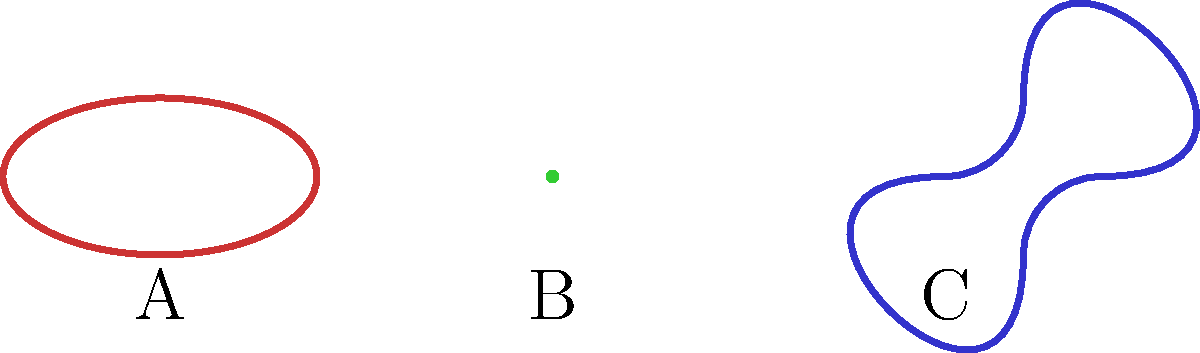As a university dean seeking to enhance student learning in astronomy, you come across this diagram illustrating three simplified shapes of galaxies. Which shape, labeled A, B, or C, most likely represents a spiral galaxy, and why would this be important for students to understand in the context of galactic evolution? To answer this question, let's analyze each shape and relate it to known galaxy types:

1. Shape A: This is an elliptical shape, characteristic of elliptical galaxies. These are typically older galaxies with little gas and dust, and minimal star formation.

2. Shape B: This is a circular shape with a slight spiral hint, most closely resembling a spiral galaxy. Spiral galaxies have a central bulge and spiral arms, often containing regions of active star formation.

3. Shape C: This irregular shape doesn't conform to a specific pattern, representative of irregular galaxies. These are often the result of galactic collisions or interactions.

The correct answer is B, as it most closely resembles a spiral galaxy. 

Understanding galaxy shapes is crucial for students in the context of galactic evolution because:

1. It helps students visualize the different stages of galactic life cycles.
2. Shape relates to the galaxy's composition, age, and star formation rate.
3. It aids in understanding galactic interactions and mergers.
4. It provides insight into the distribution of matter in the universe.
5. It helps in classifying and studying distant galaxies observed through telescopes.

By recognizing these shapes, students can better grasp the complex processes involved in galactic formation and evolution, enhancing their overall understanding of the universe's structure and history.
Answer: B (spiral galaxy) 